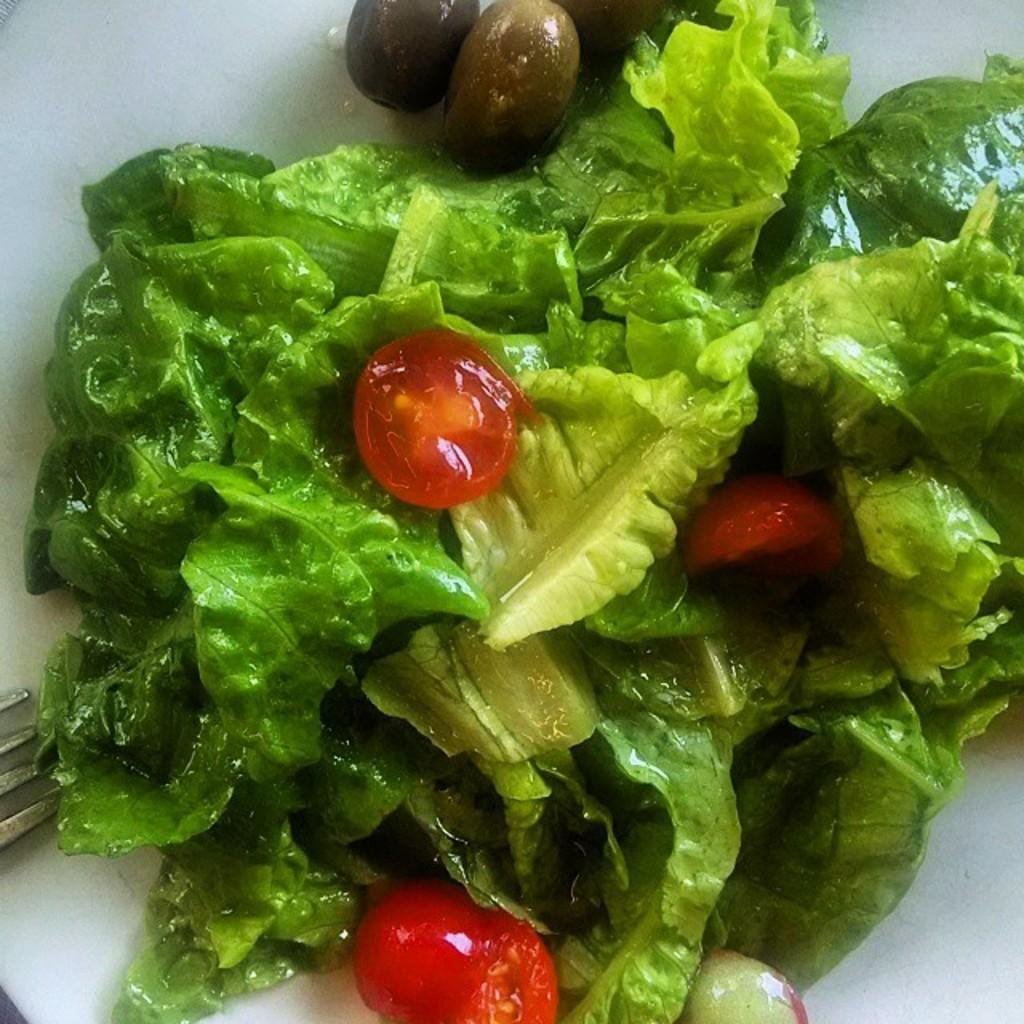In one or two sentences, can you explain what this image depicts? In this image there is a plate. On the plate there are green leaves and some vegetables. On the left side there is a fork. 